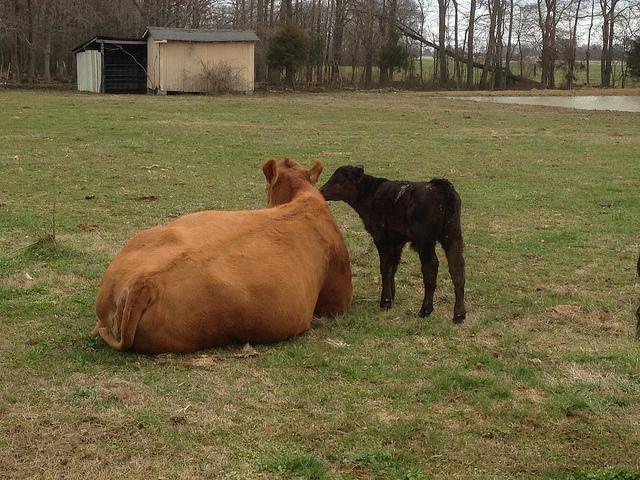What animal is standing up?
Answer briefly. Calf. Does the calf second-closest to the camera have anything around its muzzle?
Write a very short answer. No. What is covering the ground?
Short answer required. Grass. Are the cows related?
Keep it brief. Yes. Are these cows curious about the people?
Be succinct. No. How many cows are standing?
Keep it brief. 1. What kind of animal is this?
Be succinct. Cow. What is the white object in the background?
Write a very short answer. Shed. How many animals are lying down?
Write a very short answer. 1. Is the cow ready to be milked?
Quick response, please. No. Is this a horses' backend?
Answer briefly. No. How many animals can you see?
Answer briefly. 2. How many horns does the animal have?
Concise answer only. 0. How many hooves are visible?
Keep it brief. 3. Is the cow sitting on the ground or laying or did it fall?
Short answer required. Laying. What color is the small animal?
Be succinct. Black. 